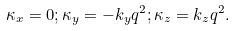<formula> <loc_0><loc_0><loc_500><loc_500>\kappa _ { x } = 0 ; \kappa _ { y } = - k _ { y } q ^ { 2 } ; \kappa _ { z } = k _ { z } q ^ { 2 } .</formula> 